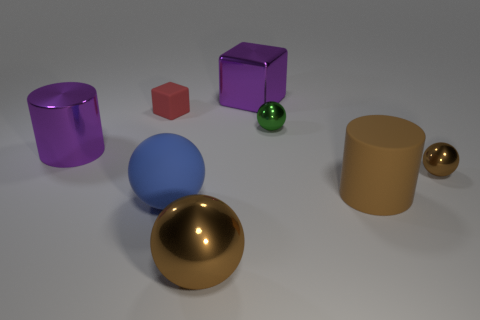What number of small green spheres are behind the blue sphere that is in front of the tiny sphere behind the tiny brown thing? There is one small green sphere located behind the blue sphere, which itself is positioned in front of a tiny sphere situated behind a small, tiny brown cube. 